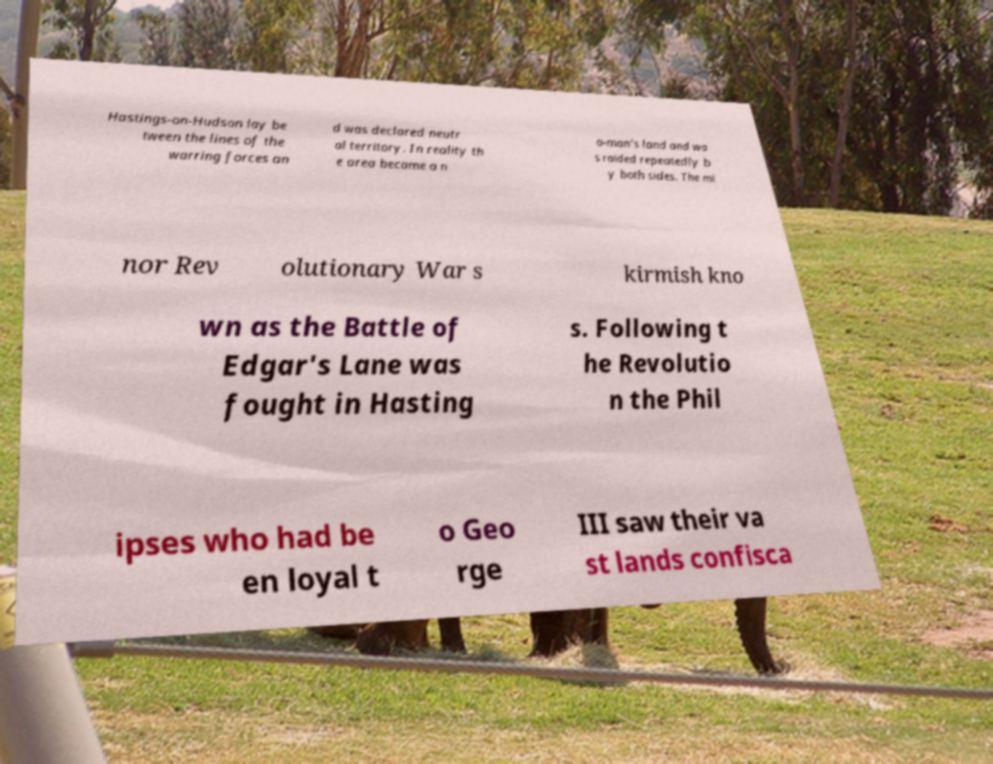Please read and relay the text visible in this image. What does it say? Hastings-on-Hudson lay be tween the lines of the warring forces an d was declared neutr al territory. In reality th e area became a n o-man's land and wa s raided repeatedly b y both sides. The mi nor Rev olutionary War s kirmish kno wn as the Battle of Edgar's Lane was fought in Hasting s. Following t he Revolutio n the Phil ipses who had be en loyal t o Geo rge III saw their va st lands confisca 